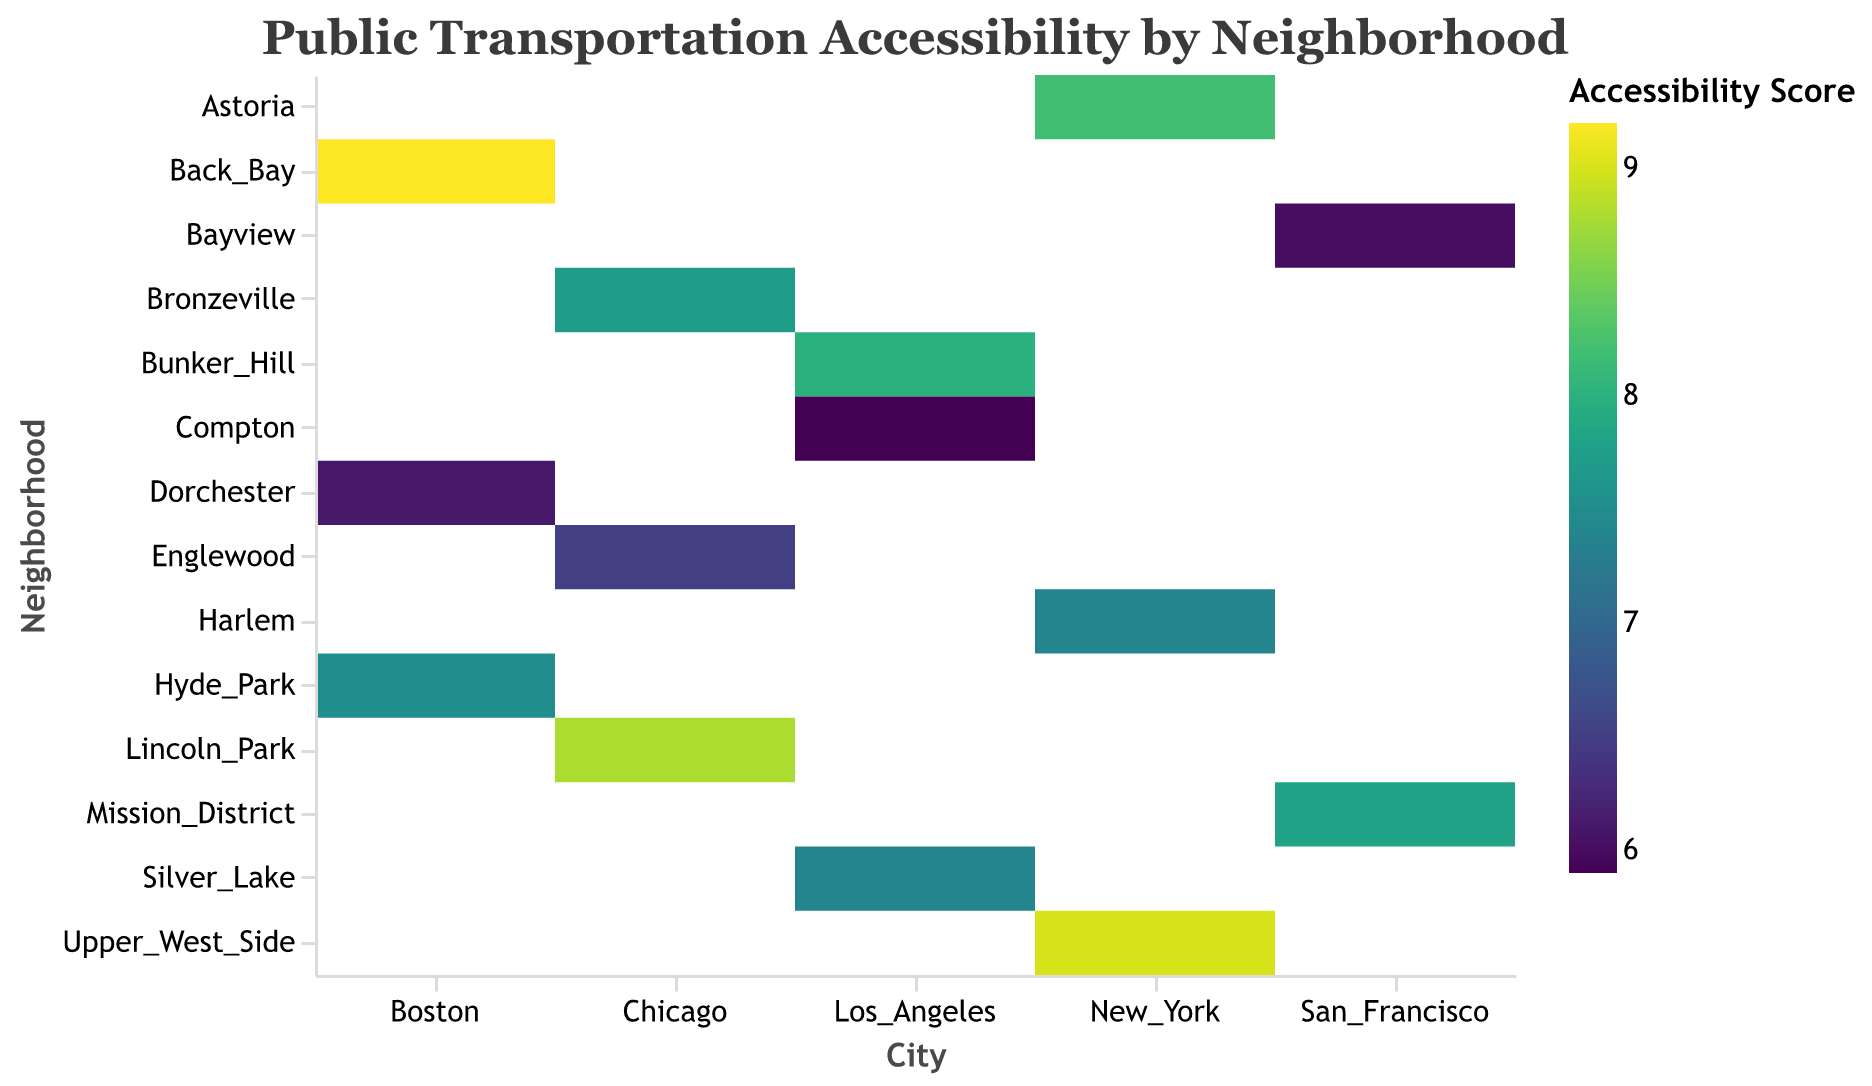What's the title of the figure? The title is located at the top of the figure and reads "Public Transportation Accessibility by Neighborhood".
Answer: Public Transportation Accessibility by Neighborhood How is the accessibility score represented in the figure? The accessibility score is represented by the color of the rectangles. A color legend on the right-hand side indicates the score range with a gradient scale from lower to higher scores.
Answer: By color gradient Which city has the neighborhood with the highest accessibility score? By examining the color legend and the colors of the rectangles, the darkest color (indicating the highest score) is found in the Back Bay neighborhood of Boston.
Answer: Boston What is the income level of the neighborhoods in Chicago with the highest accessibility score? In Chicago, the rectangles for Lincoln Park and Bronzeville have the highest accessibility scores with colors indicating higher values. Lincoln Park is labeled as High, while Bronzeville is labeled as Medium in income level.
Answer: High and Medium Which neighborhoods have a medium income level but different levels of accessibility scores? The data points for Medium income neighborhoods show colors of various intensities—Hyde Park, Silver Lake, Mission District, Astoria, and Bronzeville each have different accessibility scores ranging from lower to higher.
Answer: Hyde Park, Silver Lake, Mission District, Astoria, and Bronzeville What is the difference in accessibility scores between Astoria (New York) and Back Bay (Boston)? First, locate the score for Astoria, which is 8.2, and for Back Bay, which is 9.2. Subtract 8.2 from 9.2 to find the difference in scores.
Answer: 1.0 Which neighborhoods in Los Angeles have similar accessibility scores? By comparing the shades, Bunker Hill and Silver Lake in Los Angeles have similar color intensities indicating similar accessibility scores of 8.0 and 7.4, respectively.
Answer: Bunker Hill and Silver Lake Compare the accessibility scores of low-income neighborhoods across all cities. Which city has the lowest score for low-income neighborhoods? Examine all low-income neighborhoods and compare their colors and scores. Compton (Los Angeles) has the lowest accessibility score among the low-income neighborhoods with a score of 5.9.
Answer: Los Angeles What is the average accessibility score for neighborhoods in San Francisco? Identify the two neighborhoods in San Francisco: Mission District and Bayview. Sum their scores: 7.8 + 6.0 = 13.8, then divide by 2 to find the average.
Answer: 6.9 